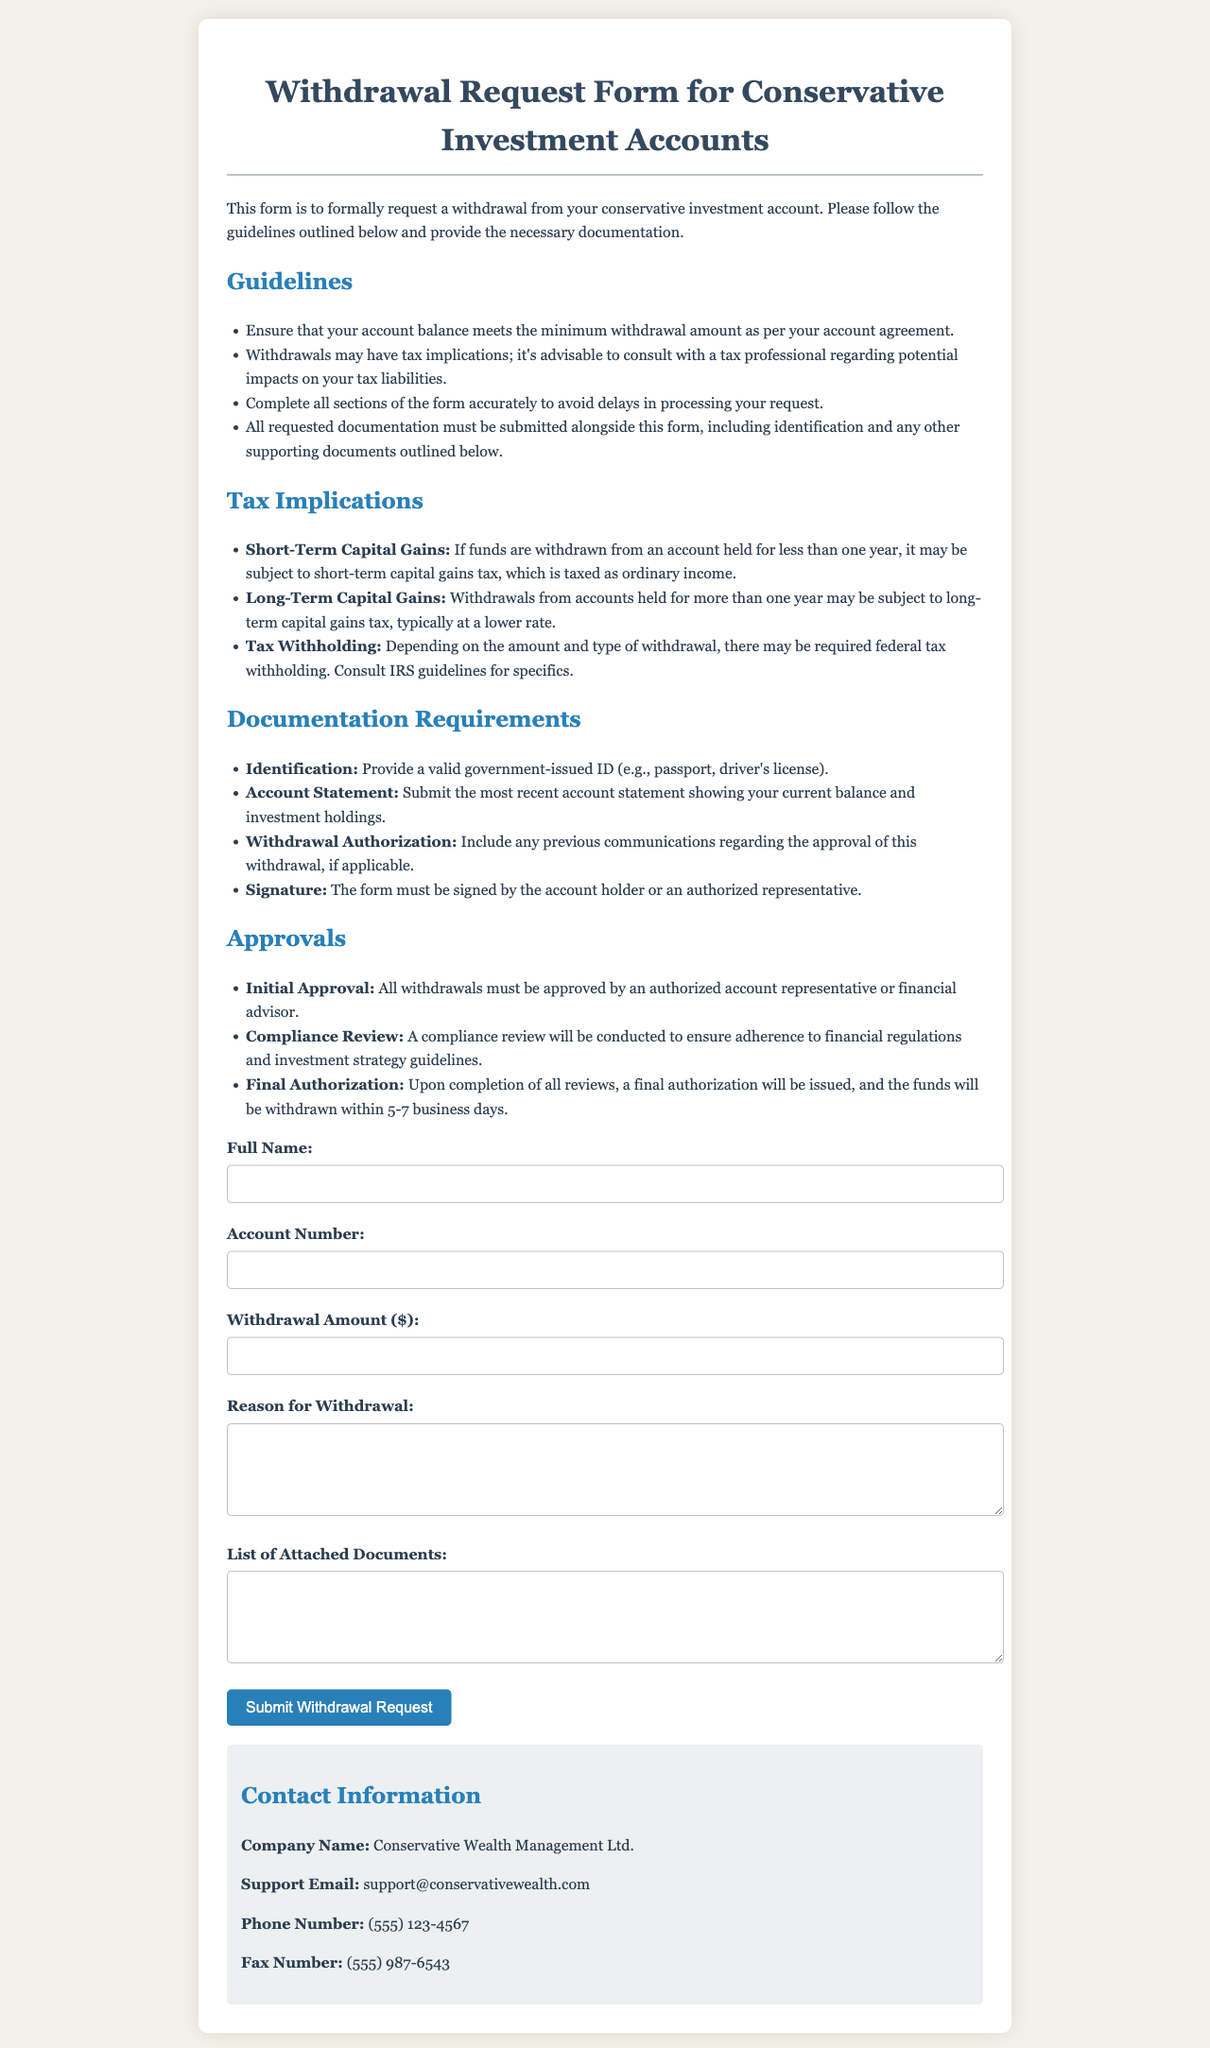what is the title of the document? The title of the document is specified in the <title> tag of the HTML, which describes the document's purpose.
Answer: Withdrawal Request Form for Conservative Investment Accounts what is the minimum requirement for submitting a withdrawal request? The minimum requirement is given in the guidelines section, stating the importance of account balance.
Answer: Minimum withdrawal amount as per account agreement what are the tax implications of a withdrawal held for less than one year? The implications are discussed in the tax implications section, detailing the classification of capital gains.
Answer: Short-Term Capital Gains what type of documentation is needed to verify identity? The required documentation for identity verification is mentioned under documentation requirements.
Answer: Valid government-issued ID how long does it take to withdraw funds once authorized? The duration for fund withdrawal is outlined under the approvals section.
Answer: 5-7 business days who must approve all withdrawals? The individual or party responsible for giving approval is specified in the approvals section.
Answer: Authorized account representative what should be included in the list of attached documents? The requirements for attached documents are described in the documentation requirements section.
Answer: Identification and supporting documents what is the support email for the company? The contact information section specifies the email address for support inquiries.
Answer: support@conservativewealth.com what is the purpose of this form? The purpose is outlined in the introductory paragraph of the document.
Answer: To formally request a withdrawal from your conservative investment account 